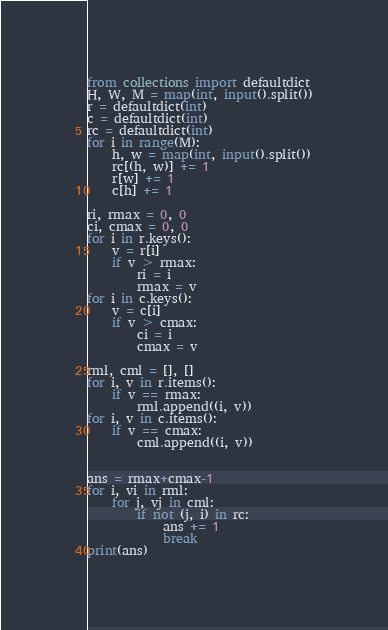<code> <loc_0><loc_0><loc_500><loc_500><_Python_>from collections import defaultdict
H, W, M = map(int, input().split())
r = defaultdict(int)
c = defaultdict(int)
rc = defaultdict(int)
for i in range(M):
    h, w = map(int, input().split())
    rc[(h, w)] += 1
    r[w] += 1
    c[h] += 1

ri, rmax = 0, 0
ci, cmax = 0, 0
for i in r.keys():
    v = r[i]
    if v > rmax:
        ri = i
        rmax = v
for i in c.keys():
    v = c[i]
    if v > cmax:
        ci = i
        cmax = v

rml, cml = [], []
for i, v in r.items():
    if v == rmax:
        rml.append((i, v))
for i, v in c.items():
    if v == cmax:
        cml.append((i, v))


ans = rmax+cmax-1
for i, vi in rml:
    for j, vj in cml:
        if not (j, i) in rc:
            ans += 1
            break
print(ans)
</code> 